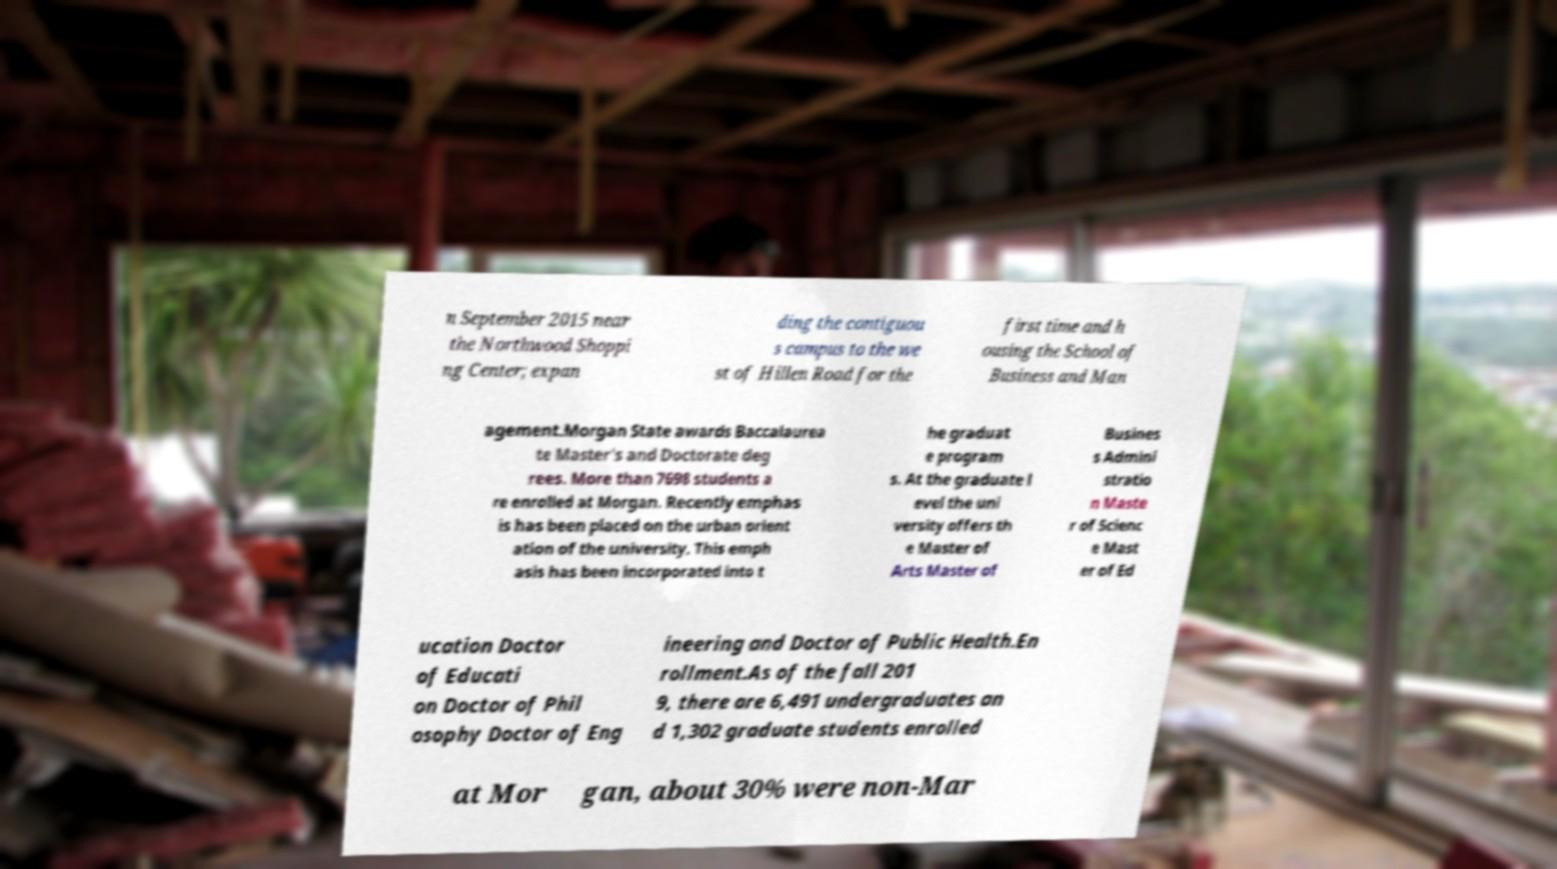Could you extract and type out the text from this image? n September 2015 near the Northwood Shoppi ng Center; expan ding the contiguou s campus to the we st of Hillen Road for the first time and h ousing the School of Business and Man agement.Morgan State awards Baccalaurea te Master's and Doctorate deg rees. More than 7698 students a re enrolled at Morgan. Recently emphas is has been placed on the urban orient ation of the university. This emph asis has been incorporated into t he graduat e program s. At the graduate l evel the uni versity offers th e Master of Arts Master of Busines s Admini stratio n Maste r of Scienc e Mast er of Ed ucation Doctor of Educati on Doctor of Phil osophy Doctor of Eng ineering and Doctor of Public Health.En rollment.As of the fall 201 9, there are 6,491 undergraduates an d 1,302 graduate students enrolled at Mor gan, about 30% were non-Mar 